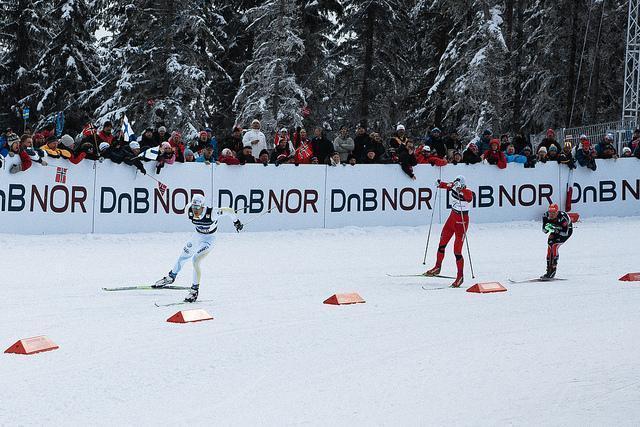How many people are there?
Give a very brief answer. 3. How many beds are in the room?
Give a very brief answer. 0. 